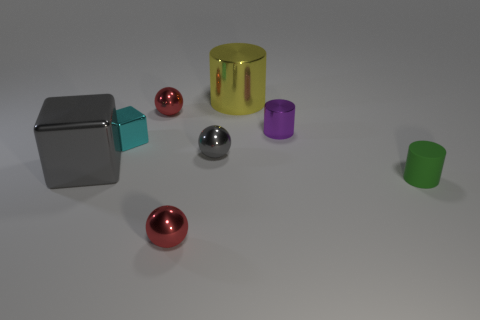Add 1 tiny purple cylinders. How many objects exist? 9 Subtract all spheres. How many objects are left? 5 Subtract 1 yellow cylinders. How many objects are left? 7 Subtract all cylinders. Subtract all large things. How many objects are left? 3 Add 4 tiny matte cylinders. How many tiny matte cylinders are left? 5 Add 4 gray metallic spheres. How many gray metallic spheres exist? 5 